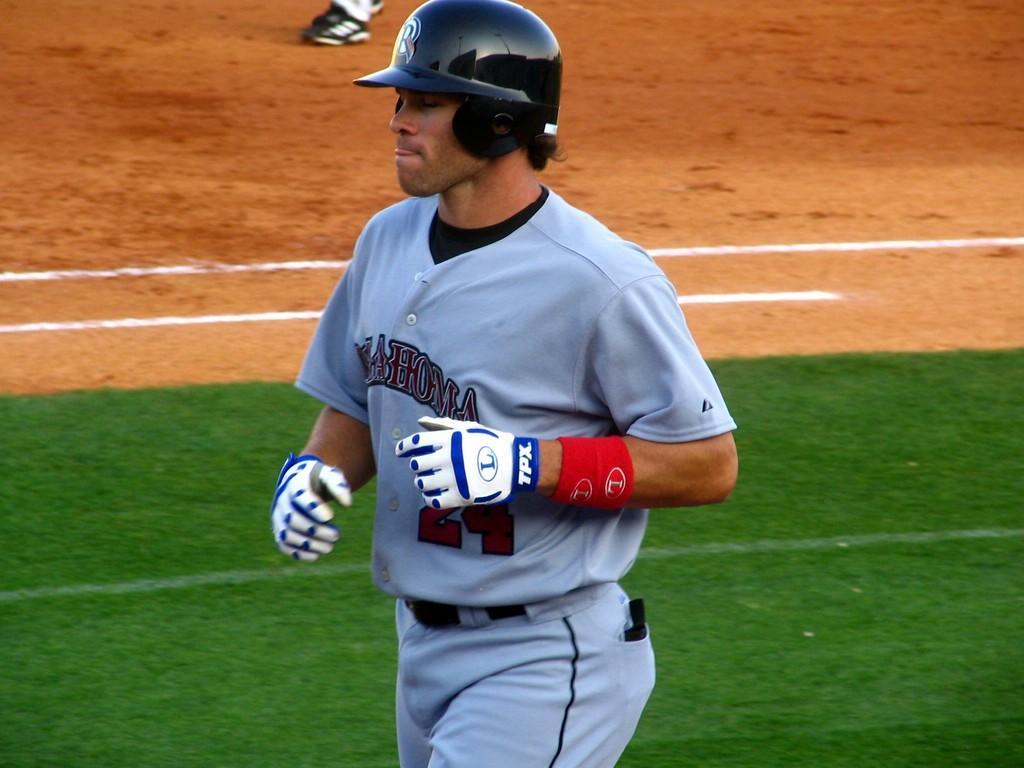Please provide a concise description of this image. In this image we can see a man wearing a helmet and the gloves standing on the ground. 